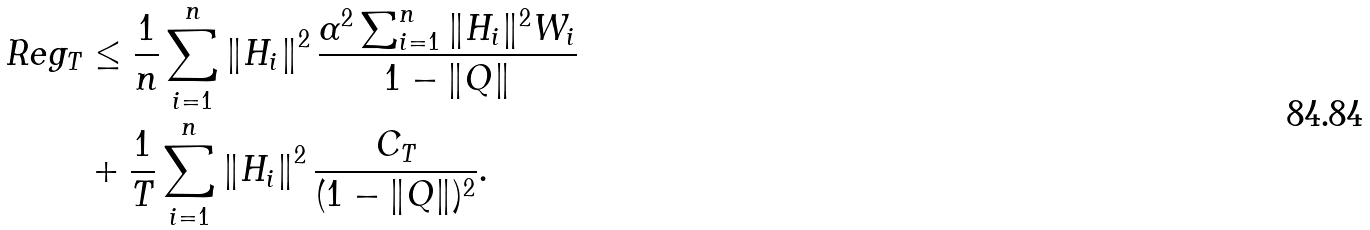<formula> <loc_0><loc_0><loc_500><loc_500>R e g _ { T } & \leq \frac { 1 } { n } \sum _ { i = 1 } ^ { n } \left \| H _ { i } \right \| ^ { 2 } \frac { \alpha ^ { 2 } \sum _ { i = 1 } ^ { n } \| H _ { i } \| ^ { 2 } W _ { i } } { 1 - \| Q \| } \\ & + \frac { 1 } { T } \sum _ { i = 1 } ^ { n } \left \| H _ { i } \right \| ^ { 2 } \frac { C _ { T } } { ( 1 - \| Q \| ) ^ { 2 } } .</formula> 